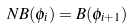<formula> <loc_0><loc_0><loc_500><loc_500>N B ( \phi _ { i } ) = B ( \phi _ { i + 1 } )</formula> 